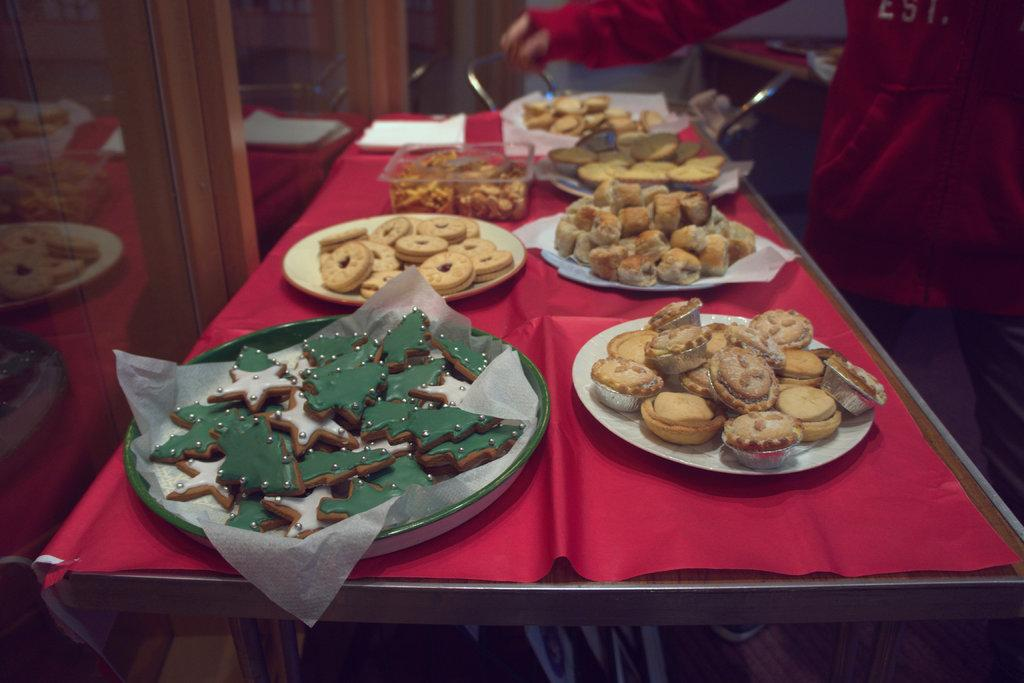What type of food items can be seen in the image? There are baked cookie items and other food items in the image. How are the food items arranged in the image? The food items are in a box and on plates. Where are the food items located in the image? The items are on a table. What can be seen in the background of the image? There is a person standing and a wall in the background of the image. What type of jewel is being used to measure the growth of the cookies in the image? There is no jewel present in the image, nor is there any indication of measuring the growth of the cookies. 